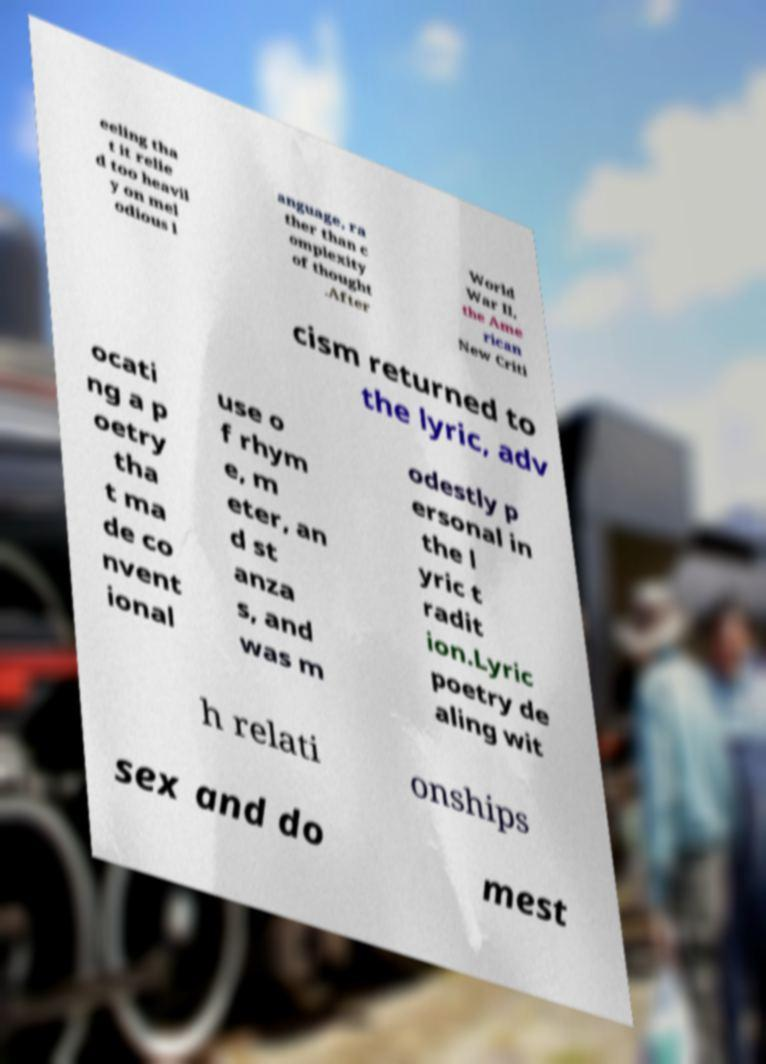There's text embedded in this image that I need extracted. Can you transcribe it verbatim? eeling tha t it relie d too heavil y on mel odious l anguage, ra ther than c omplexity of thought .After World War II, the Ame rican New Criti cism returned to the lyric, adv ocati ng a p oetry tha t ma de co nvent ional use o f rhym e, m eter, an d st anza s, and was m odestly p ersonal in the l yric t radit ion.Lyric poetry de aling wit h relati onships sex and do mest 